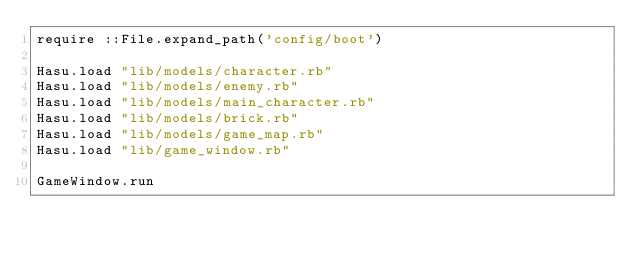<code> <loc_0><loc_0><loc_500><loc_500><_Ruby_>require ::File.expand_path('config/boot')

Hasu.load "lib/models/character.rb"
Hasu.load "lib/models/enemy.rb"
Hasu.load "lib/models/main_character.rb"
Hasu.load "lib/models/brick.rb"
Hasu.load "lib/models/game_map.rb"
Hasu.load "lib/game_window.rb"

GameWindow.run
</code> 